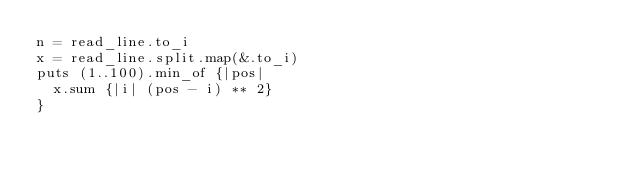<code> <loc_0><loc_0><loc_500><loc_500><_Crystal_>n = read_line.to_i
x = read_line.split.map(&.to_i)
puts (1..100).min_of {|pos|
  x.sum {|i| (pos - i) ** 2}
}</code> 